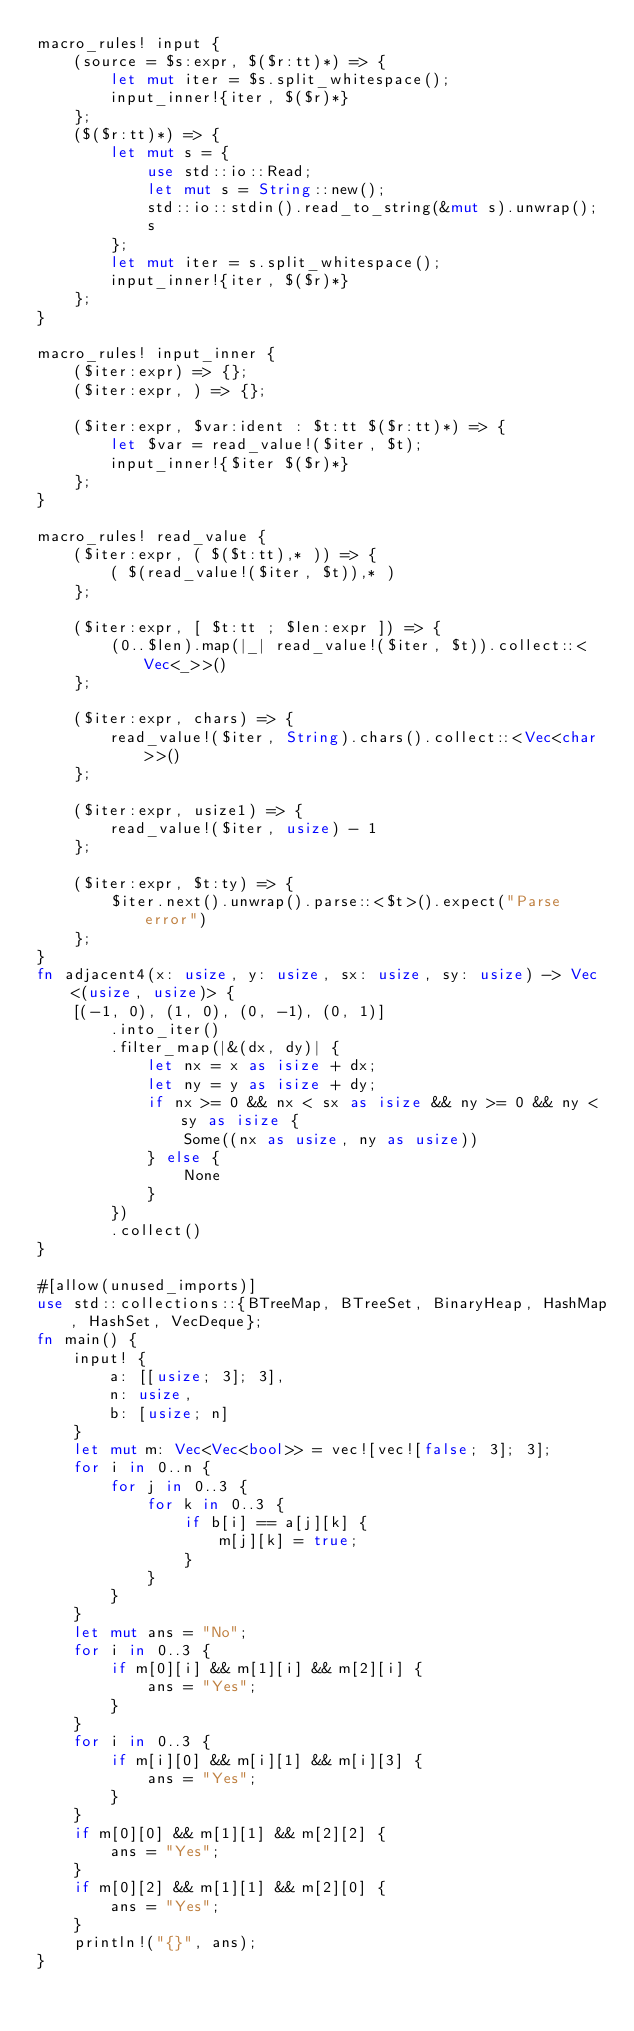Convert code to text. <code><loc_0><loc_0><loc_500><loc_500><_Rust_>macro_rules! input {
    (source = $s:expr, $($r:tt)*) => {
        let mut iter = $s.split_whitespace();
        input_inner!{iter, $($r)*}
    };
    ($($r:tt)*) => {
        let mut s = {
            use std::io::Read;
            let mut s = String::new();
            std::io::stdin().read_to_string(&mut s).unwrap();
            s
        };
        let mut iter = s.split_whitespace();
        input_inner!{iter, $($r)*}
    };
}

macro_rules! input_inner {
    ($iter:expr) => {};
    ($iter:expr, ) => {};

    ($iter:expr, $var:ident : $t:tt $($r:tt)*) => {
        let $var = read_value!($iter, $t);
        input_inner!{$iter $($r)*}
    };
}

macro_rules! read_value {
    ($iter:expr, ( $($t:tt),* )) => {
        ( $(read_value!($iter, $t)),* )
    };

    ($iter:expr, [ $t:tt ; $len:expr ]) => {
        (0..$len).map(|_| read_value!($iter, $t)).collect::<Vec<_>>()
    };

    ($iter:expr, chars) => {
        read_value!($iter, String).chars().collect::<Vec<char>>()
    };

    ($iter:expr, usize1) => {
        read_value!($iter, usize) - 1
    };

    ($iter:expr, $t:ty) => {
        $iter.next().unwrap().parse::<$t>().expect("Parse error")
    };
}
fn adjacent4(x: usize, y: usize, sx: usize, sy: usize) -> Vec<(usize, usize)> {
    [(-1, 0), (1, 0), (0, -1), (0, 1)]
        .into_iter()
        .filter_map(|&(dx, dy)| {
            let nx = x as isize + dx;
            let ny = y as isize + dy;
            if nx >= 0 && nx < sx as isize && ny >= 0 && ny < sy as isize {
                Some((nx as usize, ny as usize))
            } else {
                None
            }
        })
        .collect()
}

#[allow(unused_imports)]
use std::collections::{BTreeMap, BTreeSet, BinaryHeap, HashMap, HashSet, VecDeque};
fn main() {
    input! {
        a: [[usize; 3]; 3],
        n: usize,
        b: [usize; n]
    }
    let mut m: Vec<Vec<bool>> = vec![vec![false; 3]; 3];
    for i in 0..n {
        for j in 0..3 {
            for k in 0..3 {
                if b[i] == a[j][k] {
                    m[j][k] = true;
                }
            }
        }
    }
    let mut ans = "No";
    for i in 0..3 {
        if m[0][i] && m[1][i] && m[2][i] {
            ans = "Yes";
        }
    }
    for i in 0..3 {
        if m[i][0] && m[i][1] && m[i][3] {
            ans = "Yes";
        }
    }
    if m[0][0] && m[1][1] && m[2][2] {
        ans = "Yes";
    }
    if m[0][2] && m[1][1] && m[2][0] {
        ans = "Yes";
    }
    println!("{}", ans);
}
</code> 